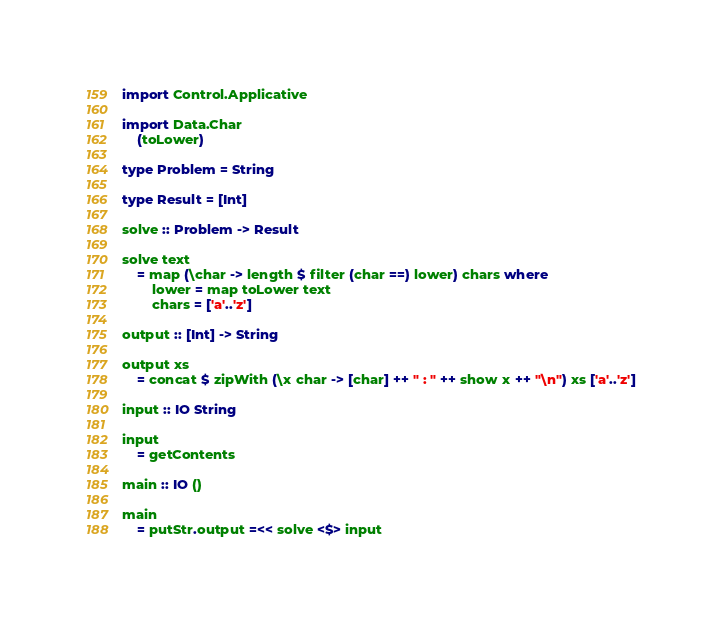Convert code to text. <code><loc_0><loc_0><loc_500><loc_500><_Haskell_>import Control.Applicative

import Data.Char
    (toLower)

type Problem = String

type Result = [Int]

solve :: Problem -> Result

solve text
    = map (\char -> length $ filter (char ==) lower) chars where
        lower = map toLower text
        chars = ['a'..'z']

output :: [Int] -> String

output xs
    = concat $ zipWith (\x char -> [char] ++ " : " ++ show x ++ "\n") xs ['a'..'z']

input :: IO String

input
    = getContents

main :: IO ()

main
    = putStr.output =<< solve <$> input</code> 